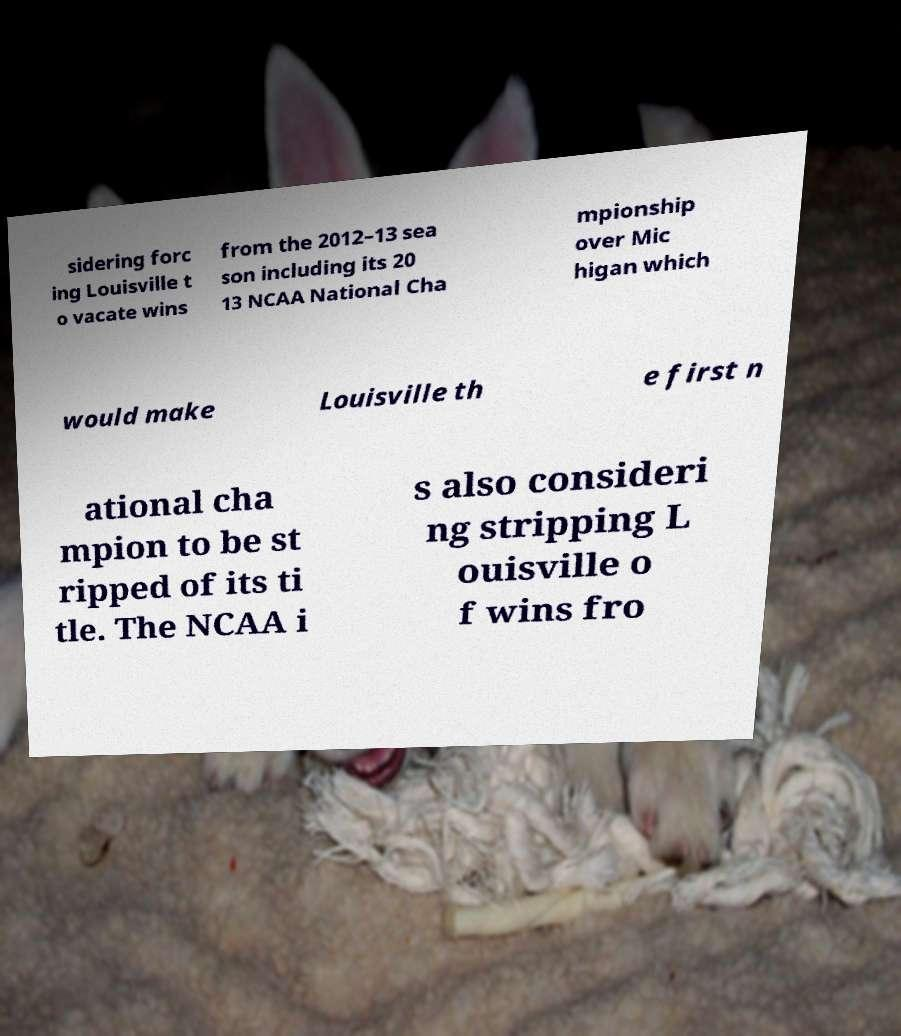What messages or text are displayed in this image? I need them in a readable, typed format. sidering forc ing Louisville t o vacate wins from the 2012–13 sea son including its 20 13 NCAA National Cha mpionship over Mic higan which would make Louisville th e first n ational cha mpion to be st ripped of its ti tle. The NCAA i s also consideri ng stripping L ouisville o f wins fro 